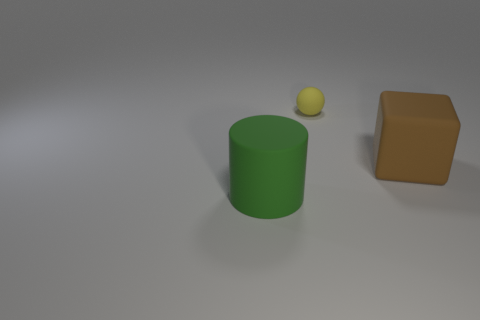Add 1 cylinders. How many objects exist? 4 Subtract all cylinders. How many objects are left? 2 Subtract 1 brown blocks. How many objects are left? 2 Subtract all big rubber cylinders. Subtract all small yellow spheres. How many objects are left? 1 Add 1 tiny matte things. How many tiny matte things are left? 2 Add 2 cyan rubber blocks. How many cyan rubber blocks exist? 2 